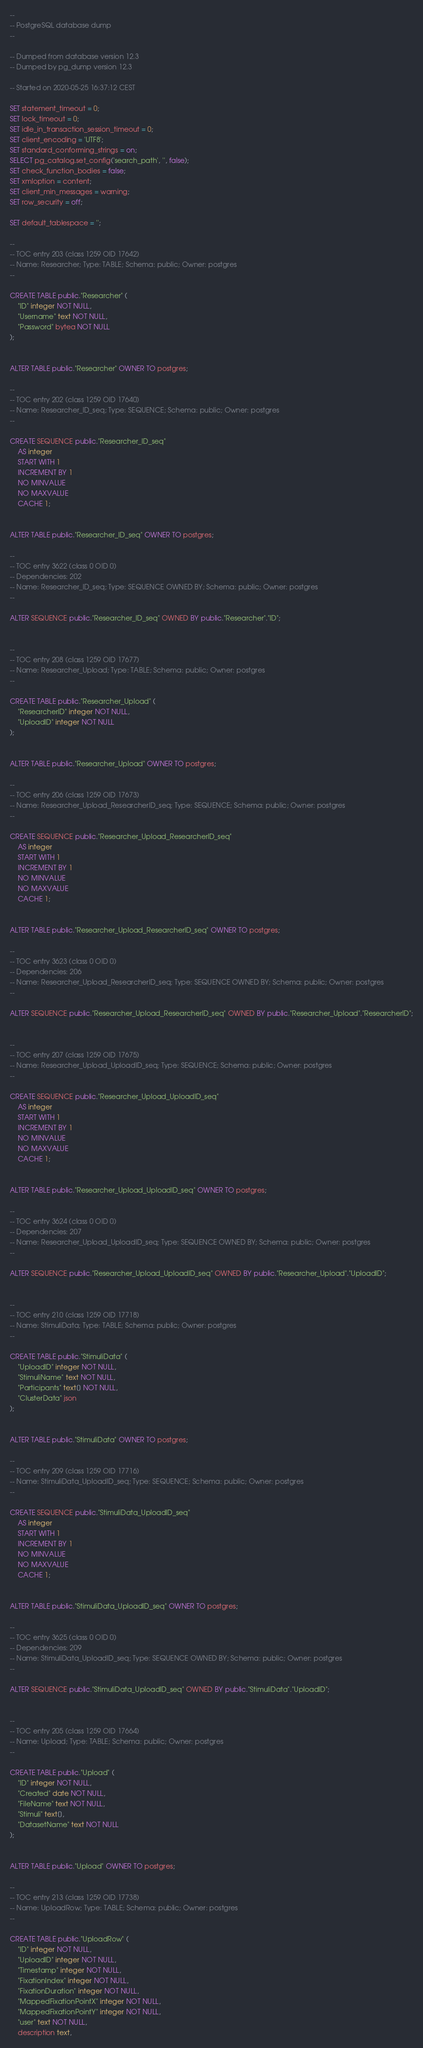Convert code to text. <code><loc_0><loc_0><loc_500><loc_500><_SQL_>--
-- PostgreSQL database dump
--

-- Dumped from database version 12.3
-- Dumped by pg_dump version 12.3

-- Started on 2020-05-25 16:37:12 CEST

SET statement_timeout = 0;
SET lock_timeout = 0;
SET idle_in_transaction_session_timeout = 0;
SET client_encoding = 'UTF8';
SET standard_conforming_strings = on;
SELECT pg_catalog.set_config('search_path', '', false);
SET check_function_bodies = false;
SET xmloption = content;
SET client_min_messages = warning;
SET row_security = off;

SET default_tablespace = '';

--
-- TOC entry 203 (class 1259 OID 17642)
-- Name: Researcher; Type: TABLE; Schema: public; Owner: postgres
--

CREATE TABLE public."Researcher" (
    "ID" integer NOT NULL,
    "Username" text NOT NULL,
    "Password" bytea NOT NULL
);


ALTER TABLE public."Researcher" OWNER TO postgres;

--
-- TOC entry 202 (class 1259 OID 17640)
-- Name: Researcher_ID_seq; Type: SEQUENCE; Schema: public; Owner: postgres
--

CREATE SEQUENCE public."Researcher_ID_seq"
    AS integer
    START WITH 1
    INCREMENT BY 1
    NO MINVALUE
    NO MAXVALUE
    CACHE 1;


ALTER TABLE public."Researcher_ID_seq" OWNER TO postgres;

--
-- TOC entry 3622 (class 0 OID 0)
-- Dependencies: 202
-- Name: Researcher_ID_seq; Type: SEQUENCE OWNED BY; Schema: public; Owner: postgres
--

ALTER SEQUENCE public."Researcher_ID_seq" OWNED BY public."Researcher"."ID";


--
-- TOC entry 208 (class 1259 OID 17677)
-- Name: Researcher_Upload; Type: TABLE; Schema: public; Owner: postgres
--

CREATE TABLE public."Researcher_Upload" (
    "ResearcherID" integer NOT NULL,
    "UploadID" integer NOT NULL
);


ALTER TABLE public."Researcher_Upload" OWNER TO postgres;

--
-- TOC entry 206 (class 1259 OID 17673)
-- Name: Researcher_Upload_ResearcherID_seq; Type: SEQUENCE; Schema: public; Owner: postgres
--

CREATE SEQUENCE public."Researcher_Upload_ResearcherID_seq"
    AS integer
    START WITH 1
    INCREMENT BY 1
    NO MINVALUE
    NO MAXVALUE
    CACHE 1;


ALTER TABLE public."Researcher_Upload_ResearcherID_seq" OWNER TO postgres;

--
-- TOC entry 3623 (class 0 OID 0)
-- Dependencies: 206
-- Name: Researcher_Upload_ResearcherID_seq; Type: SEQUENCE OWNED BY; Schema: public; Owner: postgres
--

ALTER SEQUENCE public."Researcher_Upload_ResearcherID_seq" OWNED BY public."Researcher_Upload"."ResearcherID";


--
-- TOC entry 207 (class 1259 OID 17675)
-- Name: Researcher_Upload_UploadID_seq; Type: SEQUENCE; Schema: public; Owner: postgres
--

CREATE SEQUENCE public."Researcher_Upload_UploadID_seq"
    AS integer
    START WITH 1
    INCREMENT BY 1
    NO MINVALUE
    NO MAXVALUE
    CACHE 1;


ALTER TABLE public."Researcher_Upload_UploadID_seq" OWNER TO postgres;

--
-- TOC entry 3624 (class 0 OID 0)
-- Dependencies: 207
-- Name: Researcher_Upload_UploadID_seq; Type: SEQUENCE OWNED BY; Schema: public; Owner: postgres
--

ALTER SEQUENCE public."Researcher_Upload_UploadID_seq" OWNED BY public."Researcher_Upload"."UploadID";


--
-- TOC entry 210 (class 1259 OID 17718)
-- Name: StimuliData; Type: TABLE; Schema: public; Owner: postgres
--

CREATE TABLE public."StimuliData" (
    "UploadID" integer NOT NULL,
    "StimuliName" text NOT NULL,
    "Participants" text[] NOT NULL,
    "ClusterData" json
);


ALTER TABLE public."StimuliData" OWNER TO postgres;

--
-- TOC entry 209 (class 1259 OID 17716)
-- Name: StimuliData_UploadID_seq; Type: SEQUENCE; Schema: public; Owner: postgres
--

CREATE SEQUENCE public."StimuliData_UploadID_seq"
    AS integer
    START WITH 1
    INCREMENT BY 1
    NO MINVALUE
    NO MAXVALUE
    CACHE 1;


ALTER TABLE public."StimuliData_UploadID_seq" OWNER TO postgres;

--
-- TOC entry 3625 (class 0 OID 0)
-- Dependencies: 209
-- Name: StimuliData_UploadID_seq; Type: SEQUENCE OWNED BY; Schema: public; Owner: postgres
--

ALTER SEQUENCE public."StimuliData_UploadID_seq" OWNED BY public."StimuliData"."UploadID";


--
-- TOC entry 205 (class 1259 OID 17664)
-- Name: Upload; Type: TABLE; Schema: public; Owner: postgres
--

CREATE TABLE public."Upload" (
    "ID" integer NOT NULL,
    "Created" date NOT NULL,
    "FileName" text NOT NULL,
    "Stimuli" text[],
    "DatasetName" text NOT NULL
);


ALTER TABLE public."Upload" OWNER TO postgres;

--
-- TOC entry 213 (class 1259 OID 17738)
-- Name: UploadRow; Type: TABLE; Schema: public; Owner: postgres
--

CREATE TABLE public."UploadRow" (
    "ID" integer NOT NULL,
    "UploadID" integer NOT NULL,
    "Timestamp" integer NOT NULL,
    "FixationIndex" integer NOT NULL,
    "FixationDuration" integer NOT NULL,
    "MappedFixationPointX" integer NOT NULL,
    "MappedFixationPointY" integer NOT NULL,
    "user" text NOT NULL,
    description text,</code> 